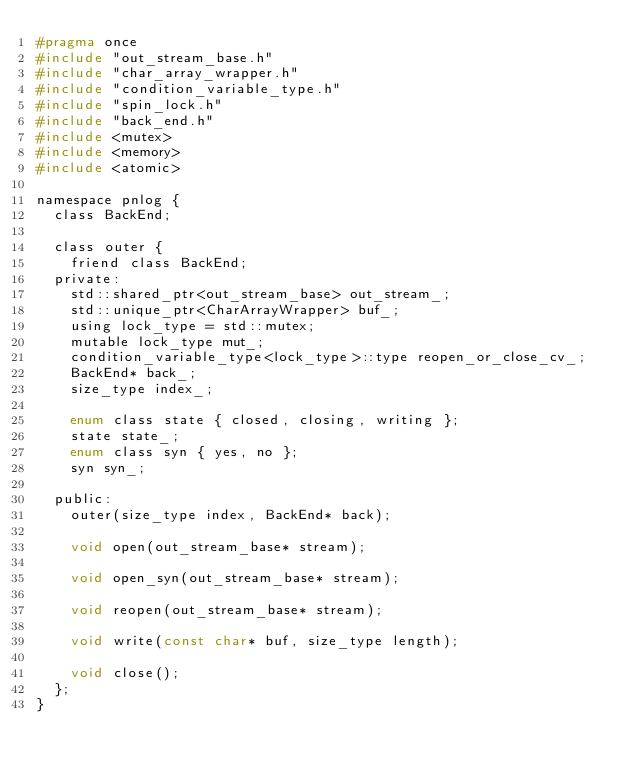Convert code to text. <code><loc_0><loc_0><loc_500><loc_500><_C_>#pragma once
#include "out_stream_base.h"
#include "char_array_wrapper.h"
#include "condition_variable_type.h"
#include "spin_lock.h"
#include "back_end.h"
#include <mutex>
#include <memory>
#include <atomic>

namespace pnlog {
  class BackEnd;

  class outer {
    friend class BackEnd;
  private:
    std::shared_ptr<out_stream_base> out_stream_;
    std::unique_ptr<CharArrayWrapper> buf_;
    using lock_type = std::mutex;
    mutable lock_type mut_;
    condition_variable_type<lock_type>::type reopen_or_close_cv_;
    BackEnd* back_;
    size_type index_;

    enum class state { closed, closing, writing };
    state state_;
    enum class syn { yes, no };
    syn syn_;

  public:
    outer(size_type index, BackEnd* back);

    void open(out_stream_base* stream);

    void open_syn(out_stream_base* stream);

    void reopen(out_stream_base* stream);

    void write(const char* buf, size_type length);

    void close();
  };
}
</code> 